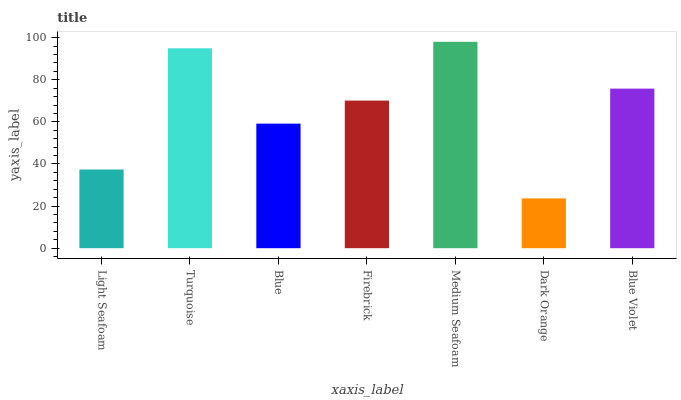Is Dark Orange the minimum?
Answer yes or no. Yes. Is Medium Seafoam the maximum?
Answer yes or no. Yes. Is Turquoise the minimum?
Answer yes or no. No. Is Turquoise the maximum?
Answer yes or no. No. Is Turquoise greater than Light Seafoam?
Answer yes or no. Yes. Is Light Seafoam less than Turquoise?
Answer yes or no. Yes. Is Light Seafoam greater than Turquoise?
Answer yes or no. No. Is Turquoise less than Light Seafoam?
Answer yes or no. No. Is Firebrick the high median?
Answer yes or no. Yes. Is Firebrick the low median?
Answer yes or no. Yes. Is Dark Orange the high median?
Answer yes or no. No. Is Medium Seafoam the low median?
Answer yes or no. No. 